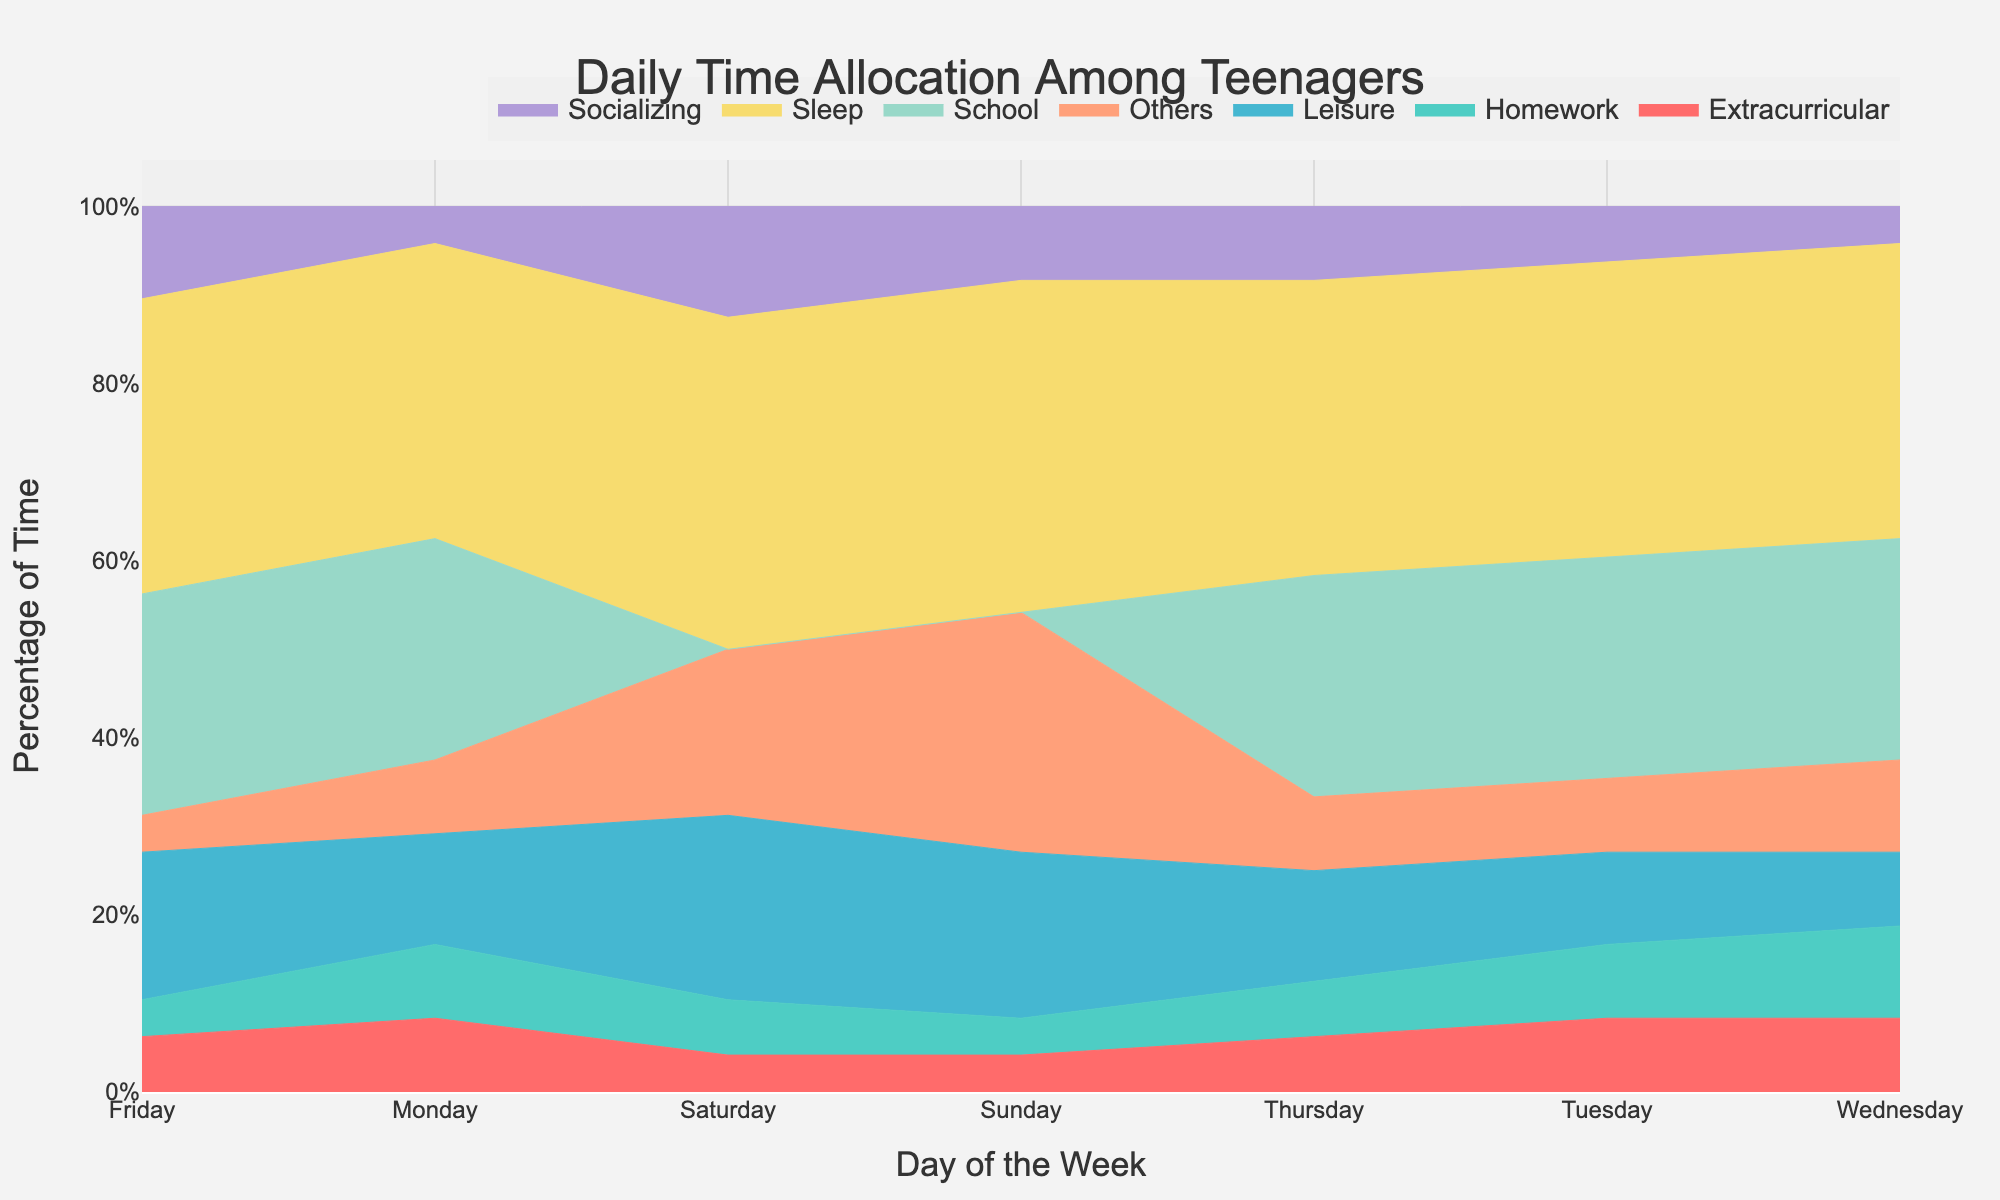What is the title of the figure? The title is generally located at the top of the figure. In this case, we know from the provided code that the title is given within the `update_layout` function under the parameter `title`.
Answer: Daily Time Allocation Among Teenagers On which day do teenagers spend the most time on Leisure activities? To find the day with the most time spent on Leisure, look for the largest portion of the stream corresponding to Leisure throughout the week. From the data, Saturday has the highest hours for Leisure.
Answer: Saturday How many activities are included in the stream graph? According to the data and the code, count the number of different activities listed.
Answer: 7 What is the average time spent on Homework over the weekdays (Monday to Friday)? Sum the time spent on Homework from Monday to Friday and divide by the number of days. (2+2+2.5+1.5+1)/5 gives us 2
Answer: 2 Which day has the greatest variety in the time spent across different activities? The day with the most diverging values for different activities would be Sunday, with times ranging from 1 to 9 hours and larger amounts for 'Others'.
Answer: Sunday How does the time spent on Socializing compare between Thursday and Friday? Look at the values for Socializing on Thursday and Friday. It is 2 hours on Thursday and 2.5 hours on Friday.
Answer: More on Friday What is the trend in Sleep time across the week? Observing the stream graph, the time allocated for Sleep stays constant at 8 hours from Monday to Friday, increasing to 9 hours on Saturday and Sunday.
Answer: Increases on weekends If you had to reduce time from one activity to add more Socializing on Wednesday, which activity would you choose and why? Analyzing the hours on Wednesday, choose an activity with a moderate to high amount that wouldn't compromise essential activities like Sleep or School. Monday's "Others" with 2.5 hours stands out.
Answer: "Others" (because it has enough time flexibly) Which activity shows the most variation in time allocation throughout the week? By visual comparison, "Others" fluctuates the most, ranging significantly each day.
Answer: "Others" What is the combined time spent on School over the week? Sum the hours spent on School across all days (6*5). Though the data only specifies weekdays, assuming the same continues makes it 30.
Answer: 30 